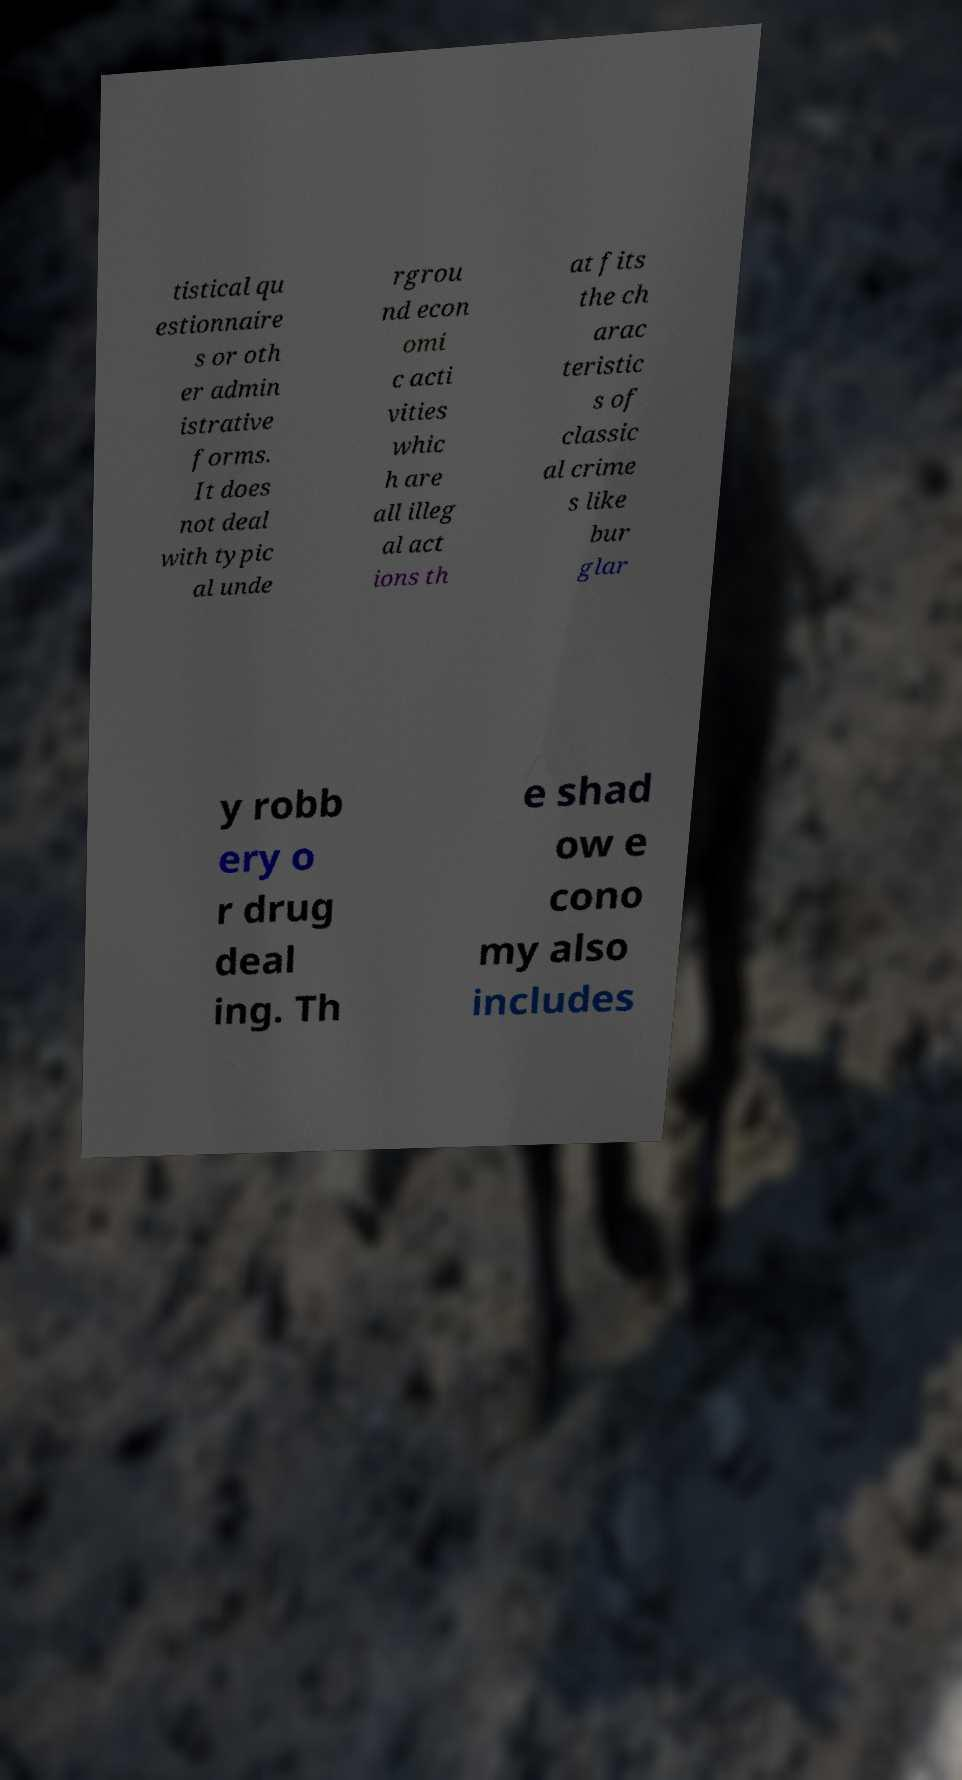Can you read and provide the text displayed in the image?This photo seems to have some interesting text. Can you extract and type it out for me? tistical qu estionnaire s or oth er admin istrative forms. It does not deal with typic al unde rgrou nd econ omi c acti vities whic h are all illeg al act ions th at fits the ch arac teristic s of classic al crime s like bur glar y robb ery o r drug deal ing. Th e shad ow e cono my also includes 